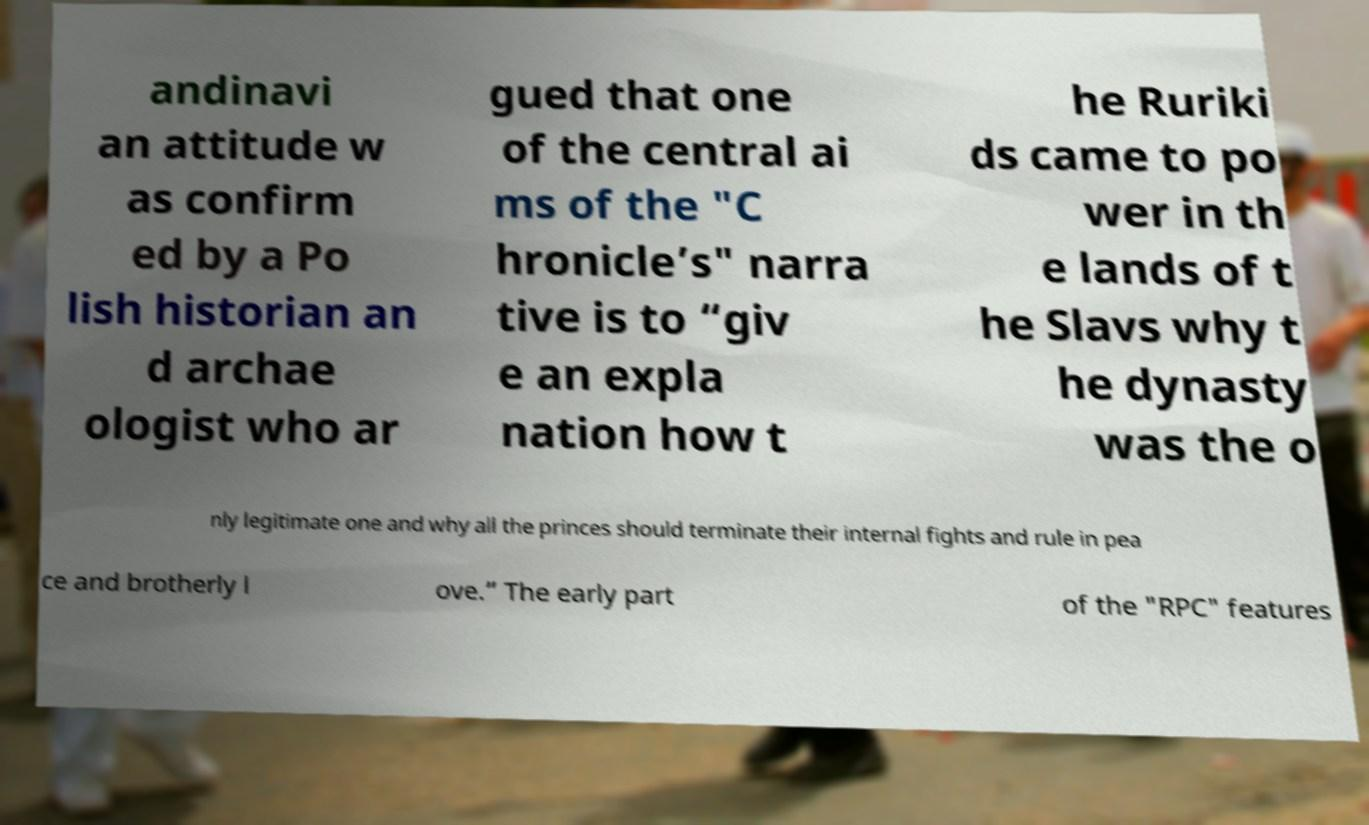What messages or text are displayed in this image? I need them in a readable, typed format. andinavi an attitude w as confirm ed by a Po lish historian an d archae ologist who ar gued that one of the central ai ms of the "C hronicle’s" narra tive is to “giv e an expla nation how t he Ruriki ds came to po wer in th e lands of t he Slavs why t he dynasty was the o nly legitimate one and why all the princes should terminate their internal fights and rule in pea ce and brotherly l ove.” The early part of the "RPC" features 